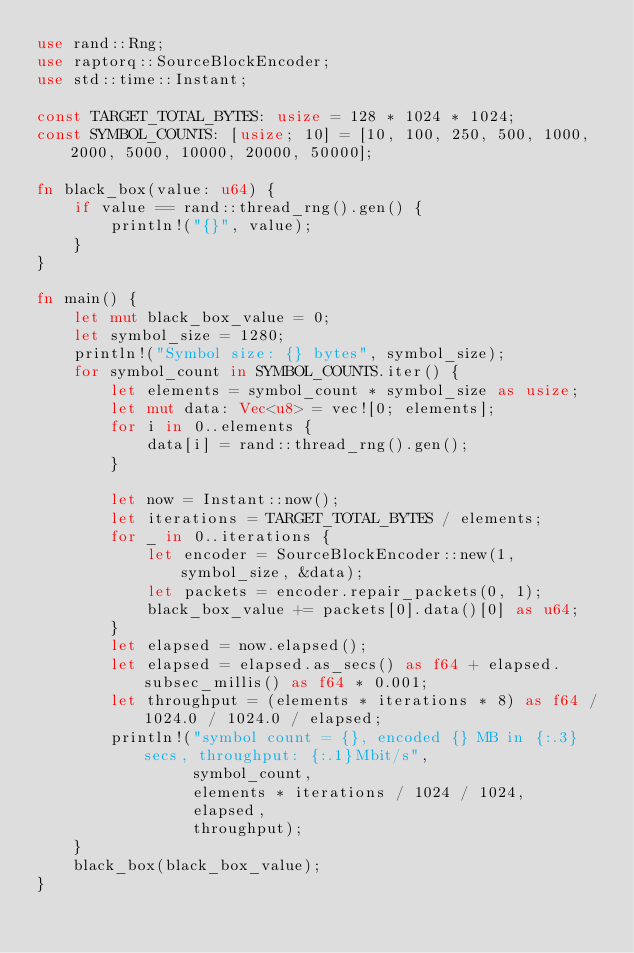<code> <loc_0><loc_0><loc_500><loc_500><_Rust_>use rand::Rng;
use raptorq::SourceBlockEncoder;
use std::time::Instant;

const TARGET_TOTAL_BYTES: usize = 128 * 1024 * 1024;
const SYMBOL_COUNTS: [usize; 10] = [10, 100, 250, 500, 1000, 2000, 5000, 10000, 20000, 50000];

fn black_box(value: u64) {
    if value == rand::thread_rng().gen() {
        println!("{}", value);
    }
}

fn main() {
    let mut black_box_value = 0;
    let symbol_size = 1280;
    println!("Symbol size: {} bytes", symbol_size);
    for symbol_count in SYMBOL_COUNTS.iter() {
        let elements = symbol_count * symbol_size as usize;
        let mut data: Vec<u8> = vec![0; elements];
        for i in 0..elements {
            data[i] = rand::thread_rng().gen();
        }

        let now = Instant::now();
        let iterations = TARGET_TOTAL_BYTES / elements;
        for _ in 0..iterations {
            let encoder = SourceBlockEncoder::new(1, symbol_size, &data);
            let packets = encoder.repair_packets(0, 1);
            black_box_value += packets[0].data()[0] as u64;
        }
        let elapsed = now.elapsed();
        let elapsed = elapsed.as_secs() as f64 + elapsed.subsec_millis() as f64 * 0.001;
        let throughput = (elements * iterations * 8) as f64 / 1024.0 / 1024.0 / elapsed;
        println!("symbol count = {}, encoded {} MB in {:.3}secs, throughput: {:.1}Mbit/s",
                 symbol_count,
                 elements * iterations / 1024 / 1024,
                 elapsed,
                 throughput);
    }
    black_box(black_box_value);
}
</code> 